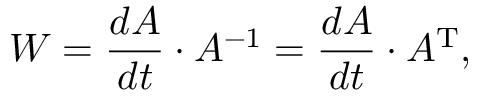Convert formula to latex. <formula><loc_0><loc_0><loc_500><loc_500>W = { \frac { d A } { d t } } \cdot A ^ { - 1 } = { \frac { d A } { d t } } \cdot A ^ { T } ,</formula> 